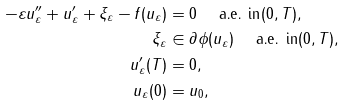Convert formula to latex. <formula><loc_0><loc_0><loc_500><loc_500>- \varepsilon u _ { \varepsilon } ^ { \prime \prime } + u _ { \varepsilon } ^ { \prime } + \xi _ { \varepsilon } - f ( u _ { \varepsilon } ) & = 0 \text { \quad a.e. in} ( 0 , T ) , \\ \xi _ { \varepsilon } & \in \partial \phi ( u _ { \varepsilon } ) \text { \quad a.e. in} ( 0 , T ) , \\ u _ { \varepsilon } ^ { \prime } ( T ) & = 0 , \\ u _ { \varepsilon } ( 0 ) & = u _ { 0 } ,</formula> 